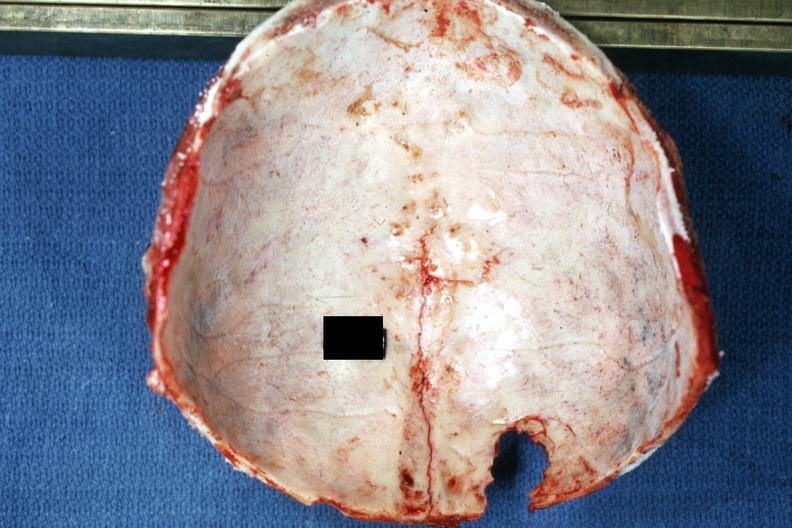s bone, calvarium present?
Answer the question using a single word or phrase. Yes 